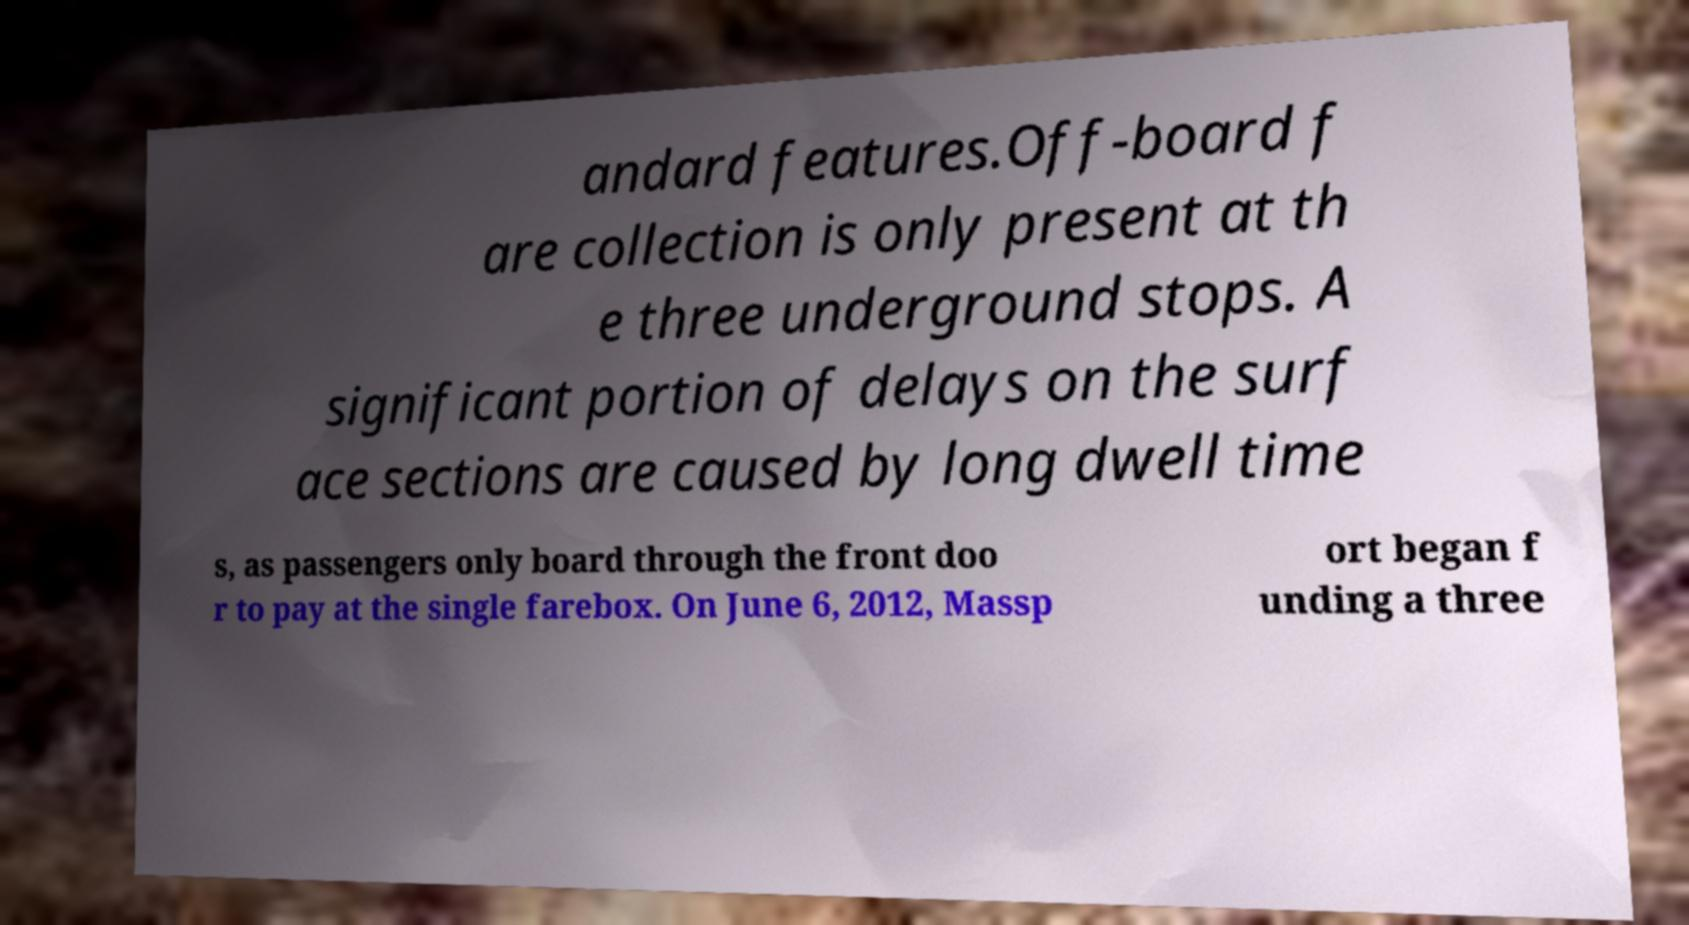For documentation purposes, I need the text within this image transcribed. Could you provide that? andard features.Off-board f are collection is only present at th e three underground stops. A significant portion of delays on the surf ace sections are caused by long dwell time s, as passengers only board through the front doo r to pay at the single farebox. On June 6, 2012, Massp ort began f unding a three 